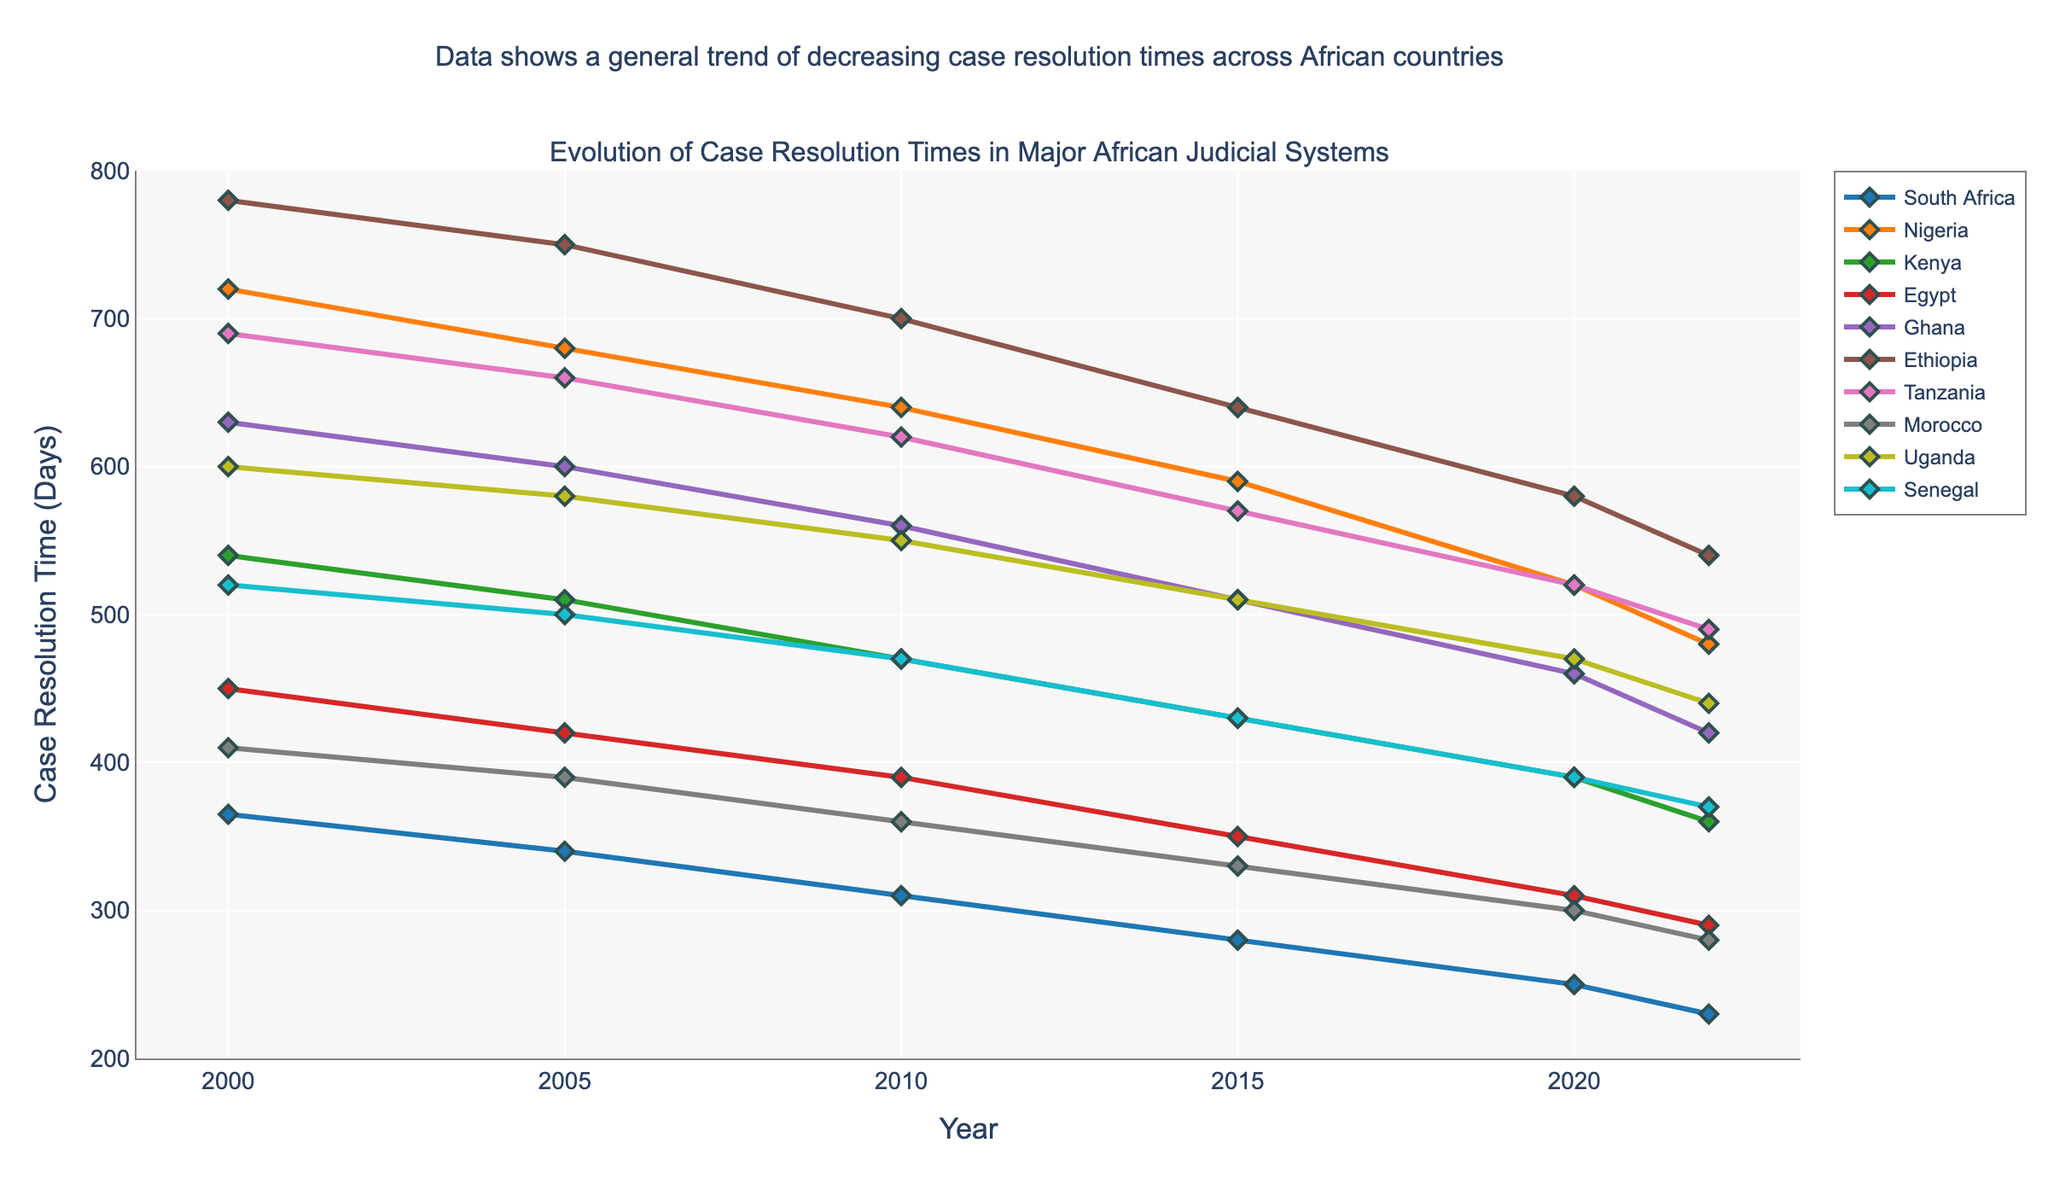How has the case resolution time in South Africa changed from 2000 to 2022? Look at the data points for South Africa from 2000 to 2022. The case resolution time decreased from 365 days in 2000 to 230 days in 2022.
Answer: It has decreased from 365 days to 230 days Which country had the longest case resolution time in 2000 and how much was it? Check the case resolution times for all countries in 2000. Ethiopia had the longest time at 780 days.
Answer: Ethiopia, 780 days Between Nigeria and Kenya, which had a greater reduction in case resolution time by 2022 compared to 2000? Calculate the difference for each country: Nigeria (720 - 480) = 240 days, Kenya (540 - 360) = 180 days. Nigeria had a greater reduction.
Answer: Nigeria had a greater reduction by 240 days Identify the country with the shortest case resolution time in 2022. Compare the 2022 data points for all countries. South Africa had the shortest time at 230 days.
Answer: South Africa, 230 days What is the average case resolution time across all countries in 2022? Add up the 2022 values and divide by the number of countries: (230 + 480 + 360 + 290 + 420 + 540 + 490 + 280 + 440 + 370) / 10 = 390 days.
Answer: 390 days Compare the case resolution times of Ghana and Morocco in 2020. Which was lower? Look at the 2020 data points for Ghana and Morocco. Ghana's was 460 days, and Morocco's was 300 days. Morocco had the lower time.
Answer: Morocco, 300 days What is the difference in case resolution time between Egypt and Uganda in 2005? Subtract Egypt's 2005 value from Uganda's 2005 value: 580 days - 420 days = 160 days.
Answer: 160 days Rank the countries by case resolution time in 2015, from highest to lowest. Compare the 2015 values: Ethiopia (640), Nigeria (590), Tanzania (570), Ghana (510), Uganda (510), Kenya (430), Senegal (430), Egypt (350), Morocco (330), South Africa (280).
Answer: Ethiopia, Nigeria, Tanzania, Ghana/Uganda, Kenya/Senegal, Egypt, Morocco, South Africa How many countries had a case resolution time of 400 days or less in 2010? Count the countries with 2010 values of 400 or less: South Africa (310), Egypt (390), Morocco (360).
Answer: 3 countries Which country showed the most improvement in case resolution time from 2005 to 2022? Calculate the differences for each country and identify the largest improvement: Ethiopia (750 - 540), Nigeria (680 - 480), Tanzania (660 - 490), Ghana (600 - 420), Uganda (580 - 440), Kenya (510 - 360), Senegal (500 - 370), Egypt (420 - 290), Morocco (390 - 280), South Africa (340 - 230). Ethiopia had the largest improvement.
Answer: Ethiopia 